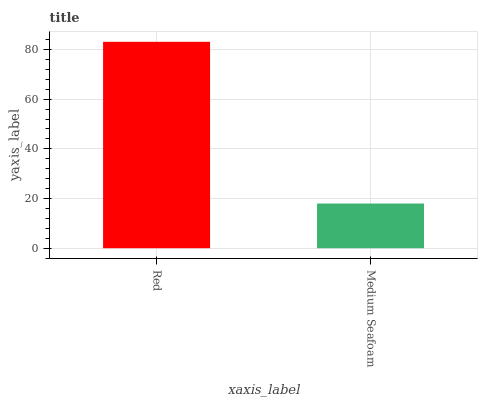Is Medium Seafoam the minimum?
Answer yes or no. Yes. Is Red the maximum?
Answer yes or no. Yes. Is Medium Seafoam the maximum?
Answer yes or no. No. Is Red greater than Medium Seafoam?
Answer yes or no. Yes. Is Medium Seafoam less than Red?
Answer yes or no. Yes. Is Medium Seafoam greater than Red?
Answer yes or no. No. Is Red less than Medium Seafoam?
Answer yes or no. No. Is Red the high median?
Answer yes or no. Yes. Is Medium Seafoam the low median?
Answer yes or no. Yes. Is Medium Seafoam the high median?
Answer yes or no. No. Is Red the low median?
Answer yes or no. No. 